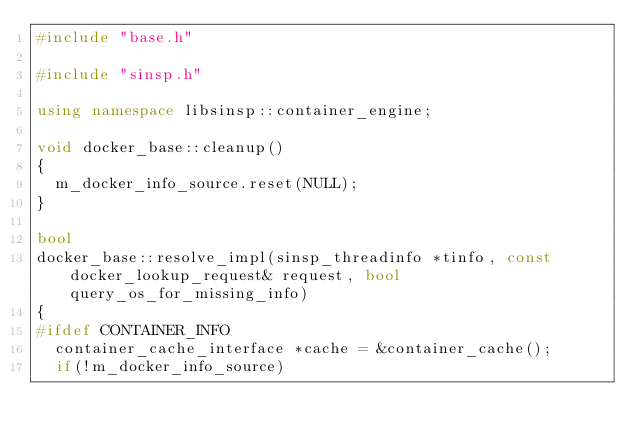Convert code to text. <code><loc_0><loc_0><loc_500><loc_500><_C++_>#include "base.h"

#include "sinsp.h"

using namespace libsinsp::container_engine;

void docker_base::cleanup()
{
	m_docker_info_source.reset(NULL);
}

bool
docker_base::resolve_impl(sinsp_threadinfo *tinfo, const docker_lookup_request& request, bool query_os_for_missing_info)
{
#ifdef CONTAINER_INFO
	container_cache_interface *cache = &container_cache();
	if(!m_docker_info_source)</code> 